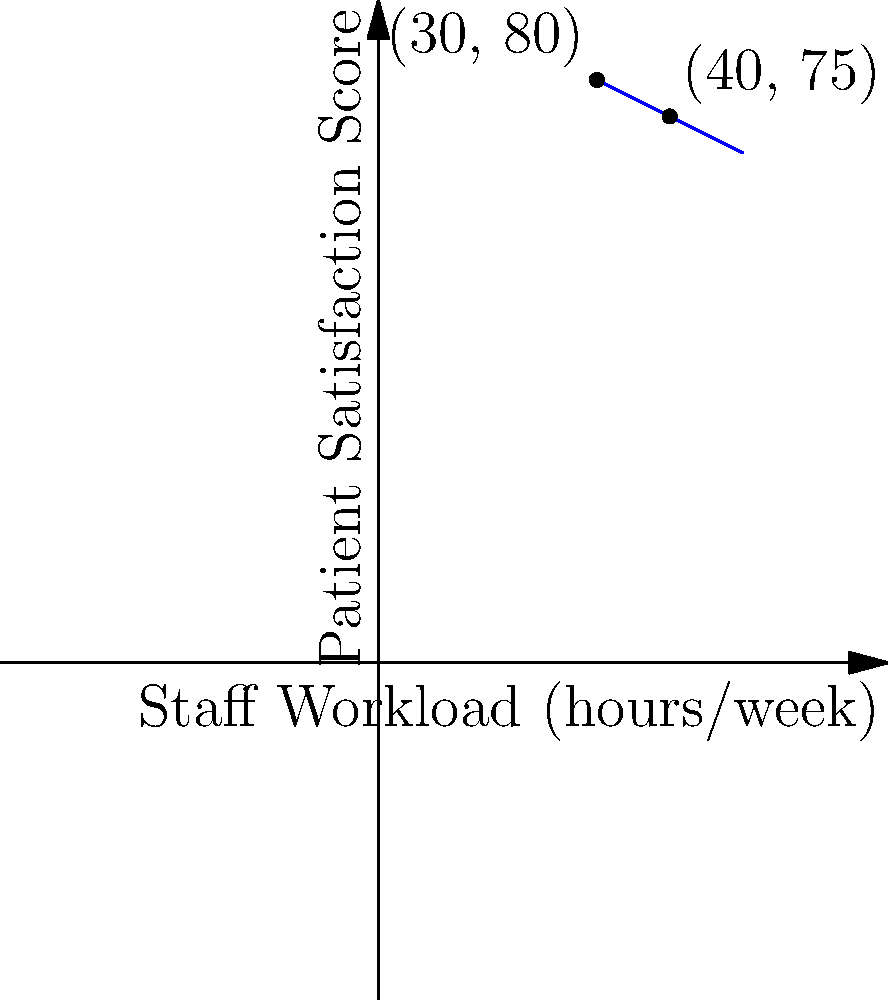The graph shows the relationship between staff workload and patient satisfaction scores in your hospital's social work department. Using the point-slope form and the points (30, 80) and (40, 75), determine the equation of the line. What would be the expected patient satisfaction score when the staff workload is 45 hours per week? 1. The point-slope form of a line is $y - y_1 = m(x - x_1)$, where $m$ is the slope and $(x_1, y_1)$ is a point on the line.

2. Calculate the slope using the two given points:
   $m = \frac{y_2 - y_1}{x_2 - x_1} = \frac{75 - 80}{40 - 30} = \frac{-5}{10} = -0.5$

3. Use the point (30, 80) and the calculated slope in the point-slope form:
   $y - 80 = -0.5(x - 30)$

4. Simplify to slope-intercept form $y = mx + b$:
   $y = -0.5x + 95$

5. To find the patient satisfaction score when staff workload is 45 hours:
   $y = -0.5(45) + 95 = -22.5 + 95 = 72.5$

Therefore, the expected patient satisfaction score when the staff workload is 45 hours per week is 72.5.
Answer: 72.5 